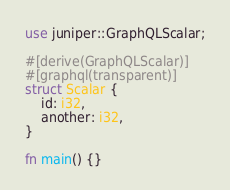<code> <loc_0><loc_0><loc_500><loc_500><_Rust_>use juniper::GraphQLScalar;

#[derive(GraphQLScalar)]
#[graphql(transparent)]
struct Scalar {
    id: i32,
    another: i32,
}

fn main() {}
</code> 